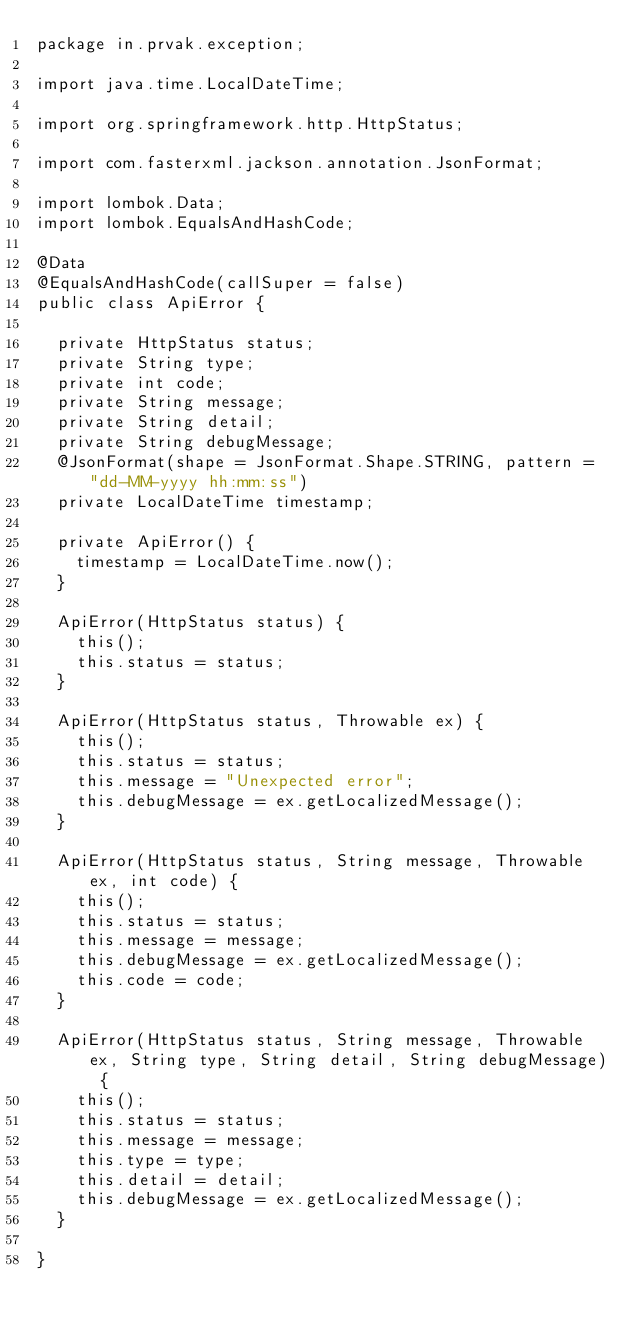<code> <loc_0><loc_0><loc_500><loc_500><_Java_>package in.prvak.exception;

import java.time.LocalDateTime;

import org.springframework.http.HttpStatus;

import com.fasterxml.jackson.annotation.JsonFormat;

import lombok.Data;
import lombok.EqualsAndHashCode;

@Data
@EqualsAndHashCode(callSuper = false)
public class ApiError {

	private HttpStatus status;
	private String type;
	private int code;
	private String message;
	private String detail;
	private String debugMessage;
	@JsonFormat(shape = JsonFormat.Shape.STRING, pattern = "dd-MM-yyyy hh:mm:ss")
	private LocalDateTime timestamp;

	private ApiError() {
		timestamp = LocalDateTime.now();
	}

	ApiError(HttpStatus status) {
		this();
		this.status = status;
	}

	ApiError(HttpStatus status, Throwable ex) {
		this();
		this.status = status;
		this.message = "Unexpected error";
		this.debugMessage = ex.getLocalizedMessage();
	}

	ApiError(HttpStatus status, String message, Throwable ex, int code) {
		this();
		this.status = status;
		this.message = message;
		this.debugMessage = ex.getLocalizedMessage();
		this.code = code;
	}

	ApiError(HttpStatus status, String message, Throwable ex, String type, String detail, String debugMessage) {
		this();
		this.status = status;
		this.message = message;
		this.type = type;
		this.detail = detail;
		this.debugMessage = ex.getLocalizedMessage();
	}

}
</code> 